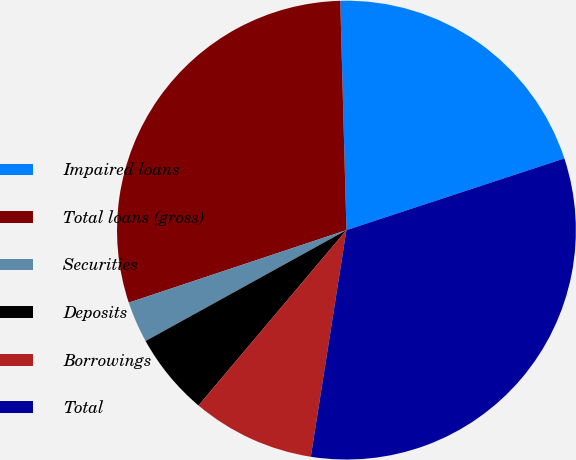Convert chart. <chart><loc_0><loc_0><loc_500><loc_500><pie_chart><fcel>Impaired loans<fcel>Total loans (gross)<fcel>Securities<fcel>Deposits<fcel>Borrowings<fcel>Total<nl><fcel>20.37%<fcel>29.69%<fcel>2.91%<fcel>5.82%<fcel>8.67%<fcel>32.54%<nl></chart> 